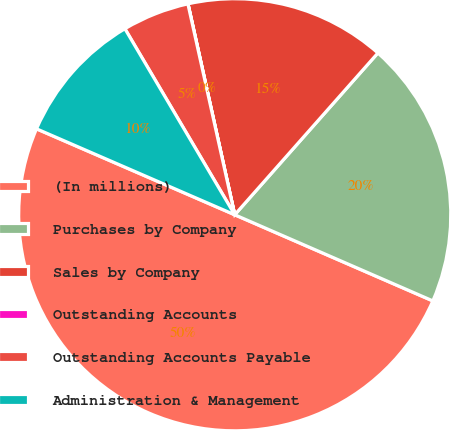Convert chart to OTSL. <chart><loc_0><loc_0><loc_500><loc_500><pie_chart><fcel>(In millions)<fcel>Purchases by Company<fcel>Sales by Company<fcel>Outstanding Accounts<fcel>Outstanding Accounts Payable<fcel>Administration & Management<nl><fcel>49.99%<fcel>20.0%<fcel>15.0%<fcel>0.01%<fcel>5.01%<fcel>10.0%<nl></chart> 